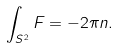Convert formula to latex. <formula><loc_0><loc_0><loc_500><loc_500>\int _ { S ^ { 2 } } F = - 2 \pi n .</formula> 